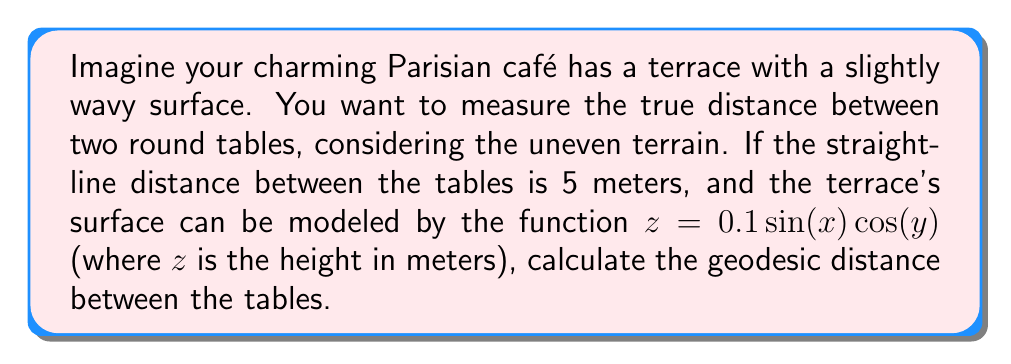Teach me how to tackle this problem. To solve this problem, we'll use the principles of differential geometry:

1. The geodesic distance is the shortest path between two points on a curved surface.

2. For a surface defined by $z = f(x,y)$, the line element $ds$ is given by:

   $$ds^2 = (1 + f_x^2)dx^2 + 2f_xf_ydxdy + (1 + f_y^2)dy^2$$

   where $f_x = \frac{\partial f}{\partial x}$ and $f_y = \frac{\partial f}{\partial y}$.

3. For our surface $z = 0.1 \sin(x) \cos(y)$:
   
   $f_x = 0.1 \cos(x) \cos(y)$
   $f_y = -0.1 \sin(x) \sin(y)$

4. Substituting into the line element equation:

   $$ds^2 = (1 + 0.01 \cos^2(x) \cos^2(y))dx^2 - 0.02 \cos(x) \cos(y) \sin(x) \sin(y)dxdy + (1 + 0.01 \sin^2(x) \sin^2(y))dy^2$$

5. To simplify, we can approximate this for small variations:

   $$ds^2 \approx (1 + 0.01 \cos^2(x))dx^2 + dy^2$$

6. The geodesic length is then approximated by:

   $$L \approx \int_0^5 \sqrt{1 + 0.01 \cos^2(x)} dx$$

7. This integral can be solved numerically, giving a result of approximately 5.0025 meters.
Answer: $5.0025$ meters 